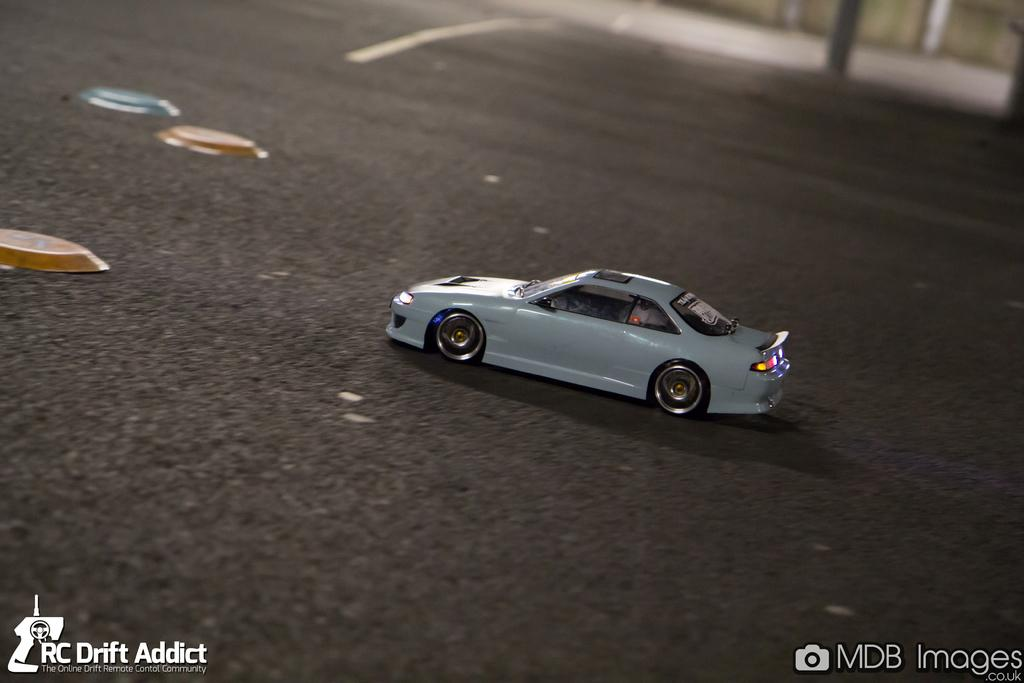What is the main subject of the image? The main subject of the image is a car. What is the car doing in the image? The car is moving on the road in the image. What color is the car? The car is white in color. How many pieces of quartz can be seen on the car in the image? There is no quartz present on the car in the image. Is there a flock of birds flying over the car in the image? There is no flock of birds visible in the image; it only features a moving white car. 